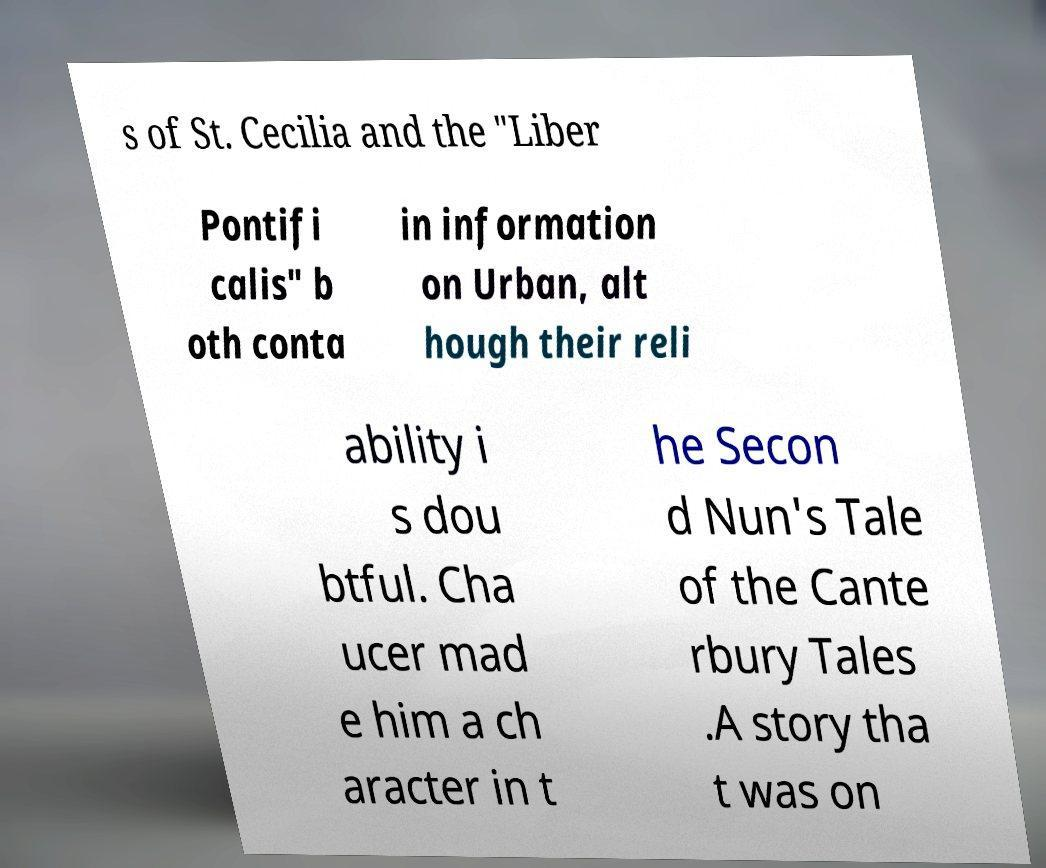I need the written content from this picture converted into text. Can you do that? s of St. Cecilia and the "Liber Pontifi calis" b oth conta in information on Urban, alt hough their reli ability i s dou btful. Cha ucer mad e him a ch aracter in t he Secon d Nun's Tale of the Cante rbury Tales .A story tha t was on 